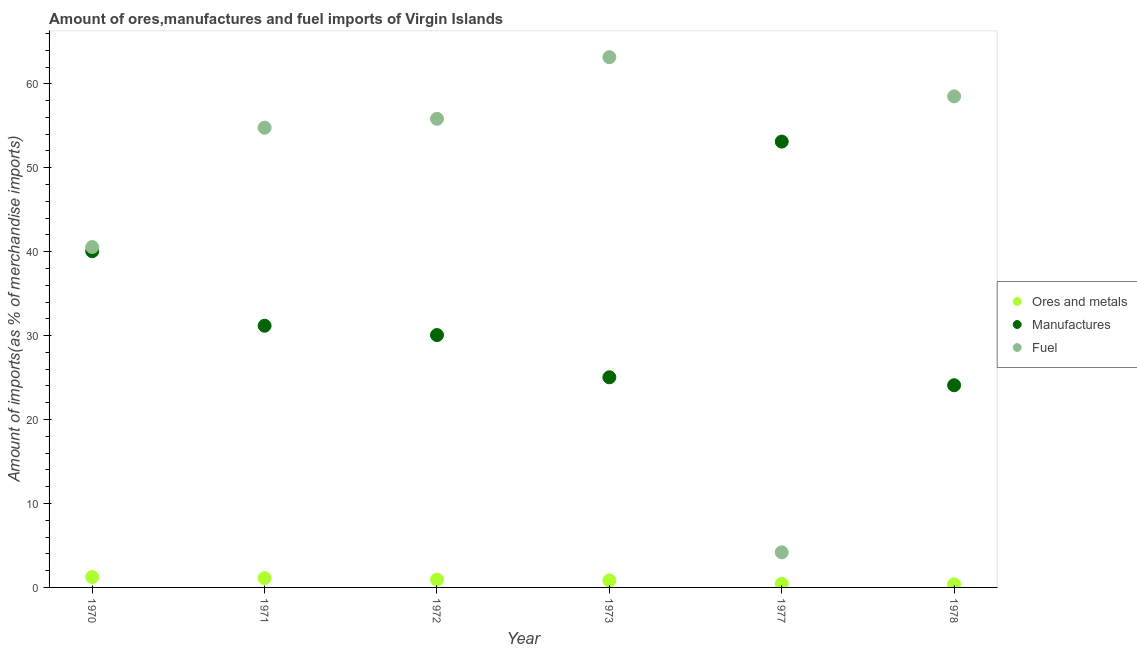How many different coloured dotlines are there?
Provide a short and direct response. 3. Is the number of dotlines equal to the number of legend labels?
Give a very brief answer. Yes. What is the percentage of ores and metals imports in 1970?
Give a very brief answer. 1.24. Across all years, what is the maximum percentage of fuel imports?
Provide a short and direct response. 63.18. Across all years, what is the minimum percentage of manufactures imports?
Ensure brevity in your answer.  24.09. In which year was the percentage of ores and metals imports minimum?
Your response must be concise. 1978. What is the total percentage of manufactures imports in the graph?
Keep it short and to the point. 203.55. What is the difference between the percentage of fuel imports in 1971 and that in 1973?
Keep it short and to the point. -8.41. What is the difference between the percentage of manufactures imports in 1977 and the percentage of ores and metals imports in 1973?
Make the answer very short. 52.28. What is the average percentage of fuel imports per year?
Keep it short and to the point. 46.17. In the year 1978, what is the difference between the percentage of manufactures imports and percentage of ores and metals imports?
Make the answer very short. 23.72. What is the ratio of the percentage of ores and metals imports in 1970 to that in 1973?
Offer a terse response. 1.48. Is the percentage of manufactures imports in 1971 less than that in 1977?
Your answer should be very brief. Yes. What is the difference between the highest and the second highest percentage of ores and metals imports?
Your answer should be very brief. 0.13. What is the difference between the highest and the lowest percentage of ores and metals imports?
Your answer should be very brief. 0.87. In how many years, is the percentage of ores and metals imports greater than the average percentage of ores and metals imports taken over all years?
Ensure brevity in your answer.  4. Is the sum of the percentage of manufactures imports in 1970 and 1973 greater than the maximum percentage of ores and metals imports across all years?
Your response must be concise. Yes. Is the percentage of manufactures imports strictly less than the percentage of ores and metals imports over the years?
Ensure brevity in your answer.  No. How many dotlines are there?
Your response must be concise. 3. Does the graph contain grids?
Give a very brief answer. No. Where does the legend appear in the graph?
Offer a terse response. Center right. What is the title of the graph?
Give a very brief answer. Amount of ores,manufactures and fuel imports of Virgin Islands. What is the label or title of the X-axis?
Make the answer very short. Year. What is the label or title of the Y-axis?
Offer a very short reply. Amount of imports(as % of merchandise imports). What is the Amount of imports(as % of merchandise imports) of Ores and metals in 1970?
Keep it short and to the point. 1.24. What is the Amount of imports(as % of merchandise imports) of Manufactures in 1970?
Make the answer very short. 40.06. What is the Amount of imports(as % of merchandise imports) in Fuel in 1970?
Ensure brevity in your answer.  40.55. What is the Amount of imports(as % of merchandise imports) in Ores and metals in 1971?
Your answer should be very brief. 1.11. What is the Amount of imports(as % of merchandise imports) in Manufactures in 1971?
Your answer should be compact. 31.18. What is the Amount of imports(as % of merchandise imports) of Fuel in 1971?
Your answer should be compact. 54.77. What is the Amount of imports(as % of merchandise imports) of Ores and metals in 1972?
Your answer should be compact. 0.93. What is the Amount of imports(as % of merchandise imports) of Manufactures in 1972?
Provide a succinct answer. 30.07. What is the Amount of imports(as % of merchandise imports) in Fuel in 1972?
Give a very brief answer. 55.83. What is the Amount of imports(as % of merchandise imports) of Ores and metals in 1973?
Give a very brief answer. 0.83. What is the Amount of imports(as % of merchandise imports) in Manufactures in 1973?
Offer a very short reply. 25.04. What is the Amount of imports(as % of merchandise imports) of Fuel in 1973?
Your answer should be compact. 63.18. What is the Amount of imports(as % of merchandise imports) of Ores and metals in 1977?
Your answer should be very brief. 0.43. What is the Amount of imports(as % of merchandise imports) in Manufactures in 1977?
Your answer should be very brief. 53.12. What is the Amount of imports(as % of merchandise imports) of Fuel in 1977?
Your response must be concise. 4.18. What is the Amount of imports(as % of merchandise imports) in Ores and metals in 1978?
Provide a succinct answer. 0.37. What is the Amount of imports(as % of merchandise imports) in Manufactures in 1978?
Offer a very short reply. 24.09. What is the Amount of imports(as % of merchandise imports) in Fuel in 1978?
Offer a very short reply. 58.5. Across all years, what is the maximum Amount of imports(as % of merchandise imports) of Ores and metals?
Make the answer very short. 1.24. Across all years, what is the maximum Amount of imports(as % of merchandise imports) in Manufactures?
Keep it short and to the point. 53.12. Across all years, what is the maximum Amount of imports(as % of merchandise imports) of Fuel?
Your answer should be very brief. 63.18. Across all years, what is the minimum Amount of imports(as % of merchandise imports) of Ores and metals?
Provide a succinct answer. 0.37. Across all years, what is the minimum Amount of imports(as % of merchandise imports) of Manufactures?
Your response must be concise. 24.09. Across all years, what is the minimum Amount of imports(as % of merchandise imports) in Fuel?
Provide a succinct answer. 4.18. What is the total Amount of imports(as % of merchandise imports) of Ores and metals in the graph?
Make the answer very short. 4.92. What is the total Amount of imports(as % of merchandise imports) of Manufactures in the graph?
Offer a very short reply. 203.55. What is the total Amount of imports(as % of merchandise imports) in Fuel in the graph?
Keep it short and to the point. 277.02. What is the difference between the Amount of imports(as % of merchandise imports) of Ores and metals in 1970 and that in 1971?
Ensure brevity in your answer.  0.13. What is the difference between the Amount of imports(as % of merchandise imports) of Manufactures in 1970 and that in 1971?
Offer a very short reply. 8.88. What is the difference between the Amount of imports(as % of merchandise imports) in Fuel in 1970 and that in 1971?
Provide a short and direct response. -14.22. What is the difference between the Amount of imports(as % of merchandise imports) of Ores and metals in 1970 and that in 1972?
Offer a very short reply. 0.31. What is the difference between the Amount of imports(as % of merchandise imports) in Manufactures in 1970 and that in 1972?
Offer a terse response. 9.99. What is the difference between the Amount of imports(as % of merchandise imports) in Fuel in 1970 and that in 1972?
Provide a succinct answer. -15.28. What is the difference between the Amount of imports(as % of merchandise imports) of Ores and metals in 1970 and that in 1973?
Keep it short and to the point. 0.4. What is the difference between the Amount of imports(as % of merchandise imports) in Manufactures in 1970 and that in 1973?
Your answer should be compact. 15.02. What is the difference between the Amount of imports(as % of merchandise imports) in Fuel in 1970 and that in 1973?
Your response must be concise. -22.62. What is the difference between the Amount of imports(as % of merchandise imports) of Ores and metals in 1970 and that in 1977?
Make the answer very short. 0.8. What is the difference between the Amount of imports(as % of merchandise imports) of Manufactures in 1970 and that in 1977?
Ensure brevity in your answer.  -13.06. What is the difference between the Amount of imports(as % of merchandise imports) in Fuel in 1970 and that in 1977?
Ensure brevity in your answer.  36.37. What is the difference between the Amount of imports(as % of merchandise imports) of Ores and metals in 1970 and that in 1978?
Your answer should be compact. 0.87. What is the difference between the Amount of imports(as % of merchandise imports) of Manufactures in 1970 and that in 1978?
Provide a succinct answer. 15.97. What is the difference between the Amount of imports(as % of merchandise imports) in Fuel in 1970 and that in 1978?
Your answer should be very brief. -17.95. What is the difference between the Amount of imports(as % of merchandise imports) of Ores and metals in 1971 and that in 1972?
Give a very brief answer. 0.18. What is the difference between the Amount of imports(as % of merchandise imports) of Manufactures in 1971 and that in 1972?
Provide a short and direct response. 1.11. What is the difference between the Amount of imports(as % of merchandise imports) in Fuel in 1971 and that in 1972?
Keep it short and to the point. -1.06. What is the difference between the Amount of imports(as % of merchandise imports) of Ores and metals in 1971 and that in 1973?
Provide a succinct answer. 0.27. What is the difference between the Amount of imports(as % of merchandise imports) in Manufactures in 1971 and that in 1973?
Your answer should be very brief. 6.14. What is the difference between the Amount of imports(as % of merchandise imports) of Fuel in 1971 and that in 1973?
Give a very brief answer. -8.41. What is the difference between the Amount of imports(as % of merchandise imports) in Ores and metals in 1971 and that in 1977?
Provide a succinct answer. 0.67. What is the difference between the Amount of imports(as % of merchandise imports) in Manufactures in 1971 and that in 1977?
Offer a very short reply. -21.94. What is the difference between the Amount of imports(as % of merchandise imports) in Fuel in 1971 and that in 1977?
Make the answer very short. 50.59. What is the difference between the Amount of imports(as % of merchandise imports) of Ores and metals in 1971 and that in 1978?
Offer a terse response. 0.74. What is the difference between the Amount of imports(as % of merchandise imports) in Manufactures in 1971 and that in 1978?
Your answer should be compact. 7.09. What is the difference between the Amount of imports(as % of merchandise imports) in Fuel in 1971 and that in 1978?
Your answer should be compact. -3.74. What is the difference between the Amount of imports(as % of merchandise imports) of Ores and metals in 1972 and that in 1973?
Make the answer very short. 0.09. What is the difference between the Amount of imports(as % of merchandise imports) of Manufactures in 1972 and that in 1973?
Provide a short and direct response. 5.03. What is the difference between the Amount of imports(as % of merchandise imports) of Fuel in 1972 and that in 1973?
Make the answer very short. -7.34. What is the difference between the Amount of imports(as % of merchandise imports) of Ores and metals in 1972 and that in 1977?
Give a very brief answer. 0.49. What is the difference between the Amount of imports(as % of merchandise imports) in Manufactures in 1972 and that in 1977?
Offer a terse response. -23.05. What is the difference between the Amount of imports(as % of merchandise imports) of Fuel in 1972 and that in 1977?
Provide a succinct answer. 51.65. What is the difference between the Amount of imports(as % of merchandise imports) in Ores and metals in 1972 and that in 1978?
Provide a succinct answer. 0.56. What is the difference between the Amount of imports(as % of merchandise imports) in Manufactures in 1972 and that in 1978?
Your answer should be compact. 5.98. What is the difference between the Amount of imports(as % of merchandise imports) of Fuel in 1972 and that in 1978?
Provide a succinct answer. -2.67. What is the difference between the Amount of imports(as % of merchandise imports) of Ores and metals in 1973 and that in 1977?
Give a very brief answer. 0.4. What is the difference between the Amount of imports(as % of merchandise imports) of Manufactures in 1973 and that in 1977?
Keep it short and to the point. -28.08. What is the difference between the Amount of imports(as % of merchandise imports) in Fuel in 1973 and that in 1977?
Your answer should be very brief. 59. What is the difference between the Amount of imports(as % of merchandise imports) of Ores and metals in 1973 and that in 1978?
Your answer should be compact. 0.46. What is the difference between the Amount of imports(as % of merchandise imports) in Manufactures in 1973 and that in 1978?
Your answer should be compact. 0.95. What is the difference between the Amount of imports(as % of merchandise imports) in Fuel in 1973 and that in 1978?
Your answer should be compact. 4.67. What is the difference between the Amount of imports(as % of merchandise imports) in Ores and metals in 1977 and that in 1978?
Provide a short and direct response. 0.06. What is the difference between the Amount of imports(as % of merchandise imports) of Manufactures in 1977 and that in 1978?
Offer a terse response. 29.03. What is the difference between the Amount of imports(as % of merchandise imports) of Fuel in 1977 and that in 1978?
Provide a succinct answer. -54.32. What is the difference between the Amount of imports(as % of merchandise imports) of Ores and metals in 1970 and the Amount of imports(as % of merchandise imports) of Manufactures in 1971?
Make the answer very short. -29.94. What is the difference between the Amount of imports(as % of merchandise imports) of Ores and metals in 1970 and the Amount of imports(as % of merchandise imports) of Fuel in 1971?
Your answer should be very brief. -53.53. What is the difference between the Amount of imports(as % of merchandise imports) of Manufactures in 1970 and the Amount of imports(as % of merchandise imports) of Fuel in 1971?
Ensure brevity in your answer.  -14.71. What is the difference between the Amount of imports(as % of merchandise imports) in Ores and metals in 1970 and the Amount of imports(as % of merchandise imports) in Manufactures in 1972?
Ensure brevity in your answer.  -28.83. What is the difference between the Amount of imports(as % of merchandise imports) of Ores and metals in 1970 and the Amount of imports(as % of merchandise imports) of Fuel in 1972?
Offer a terse response. -54.59. What is the difference between the Amount of imports(as % of merchandise imports) in Manufactures in 1970 and the Amount of imports(as % of merchandise imports) in Fuel in 1972?
Ensure brevity in your answer.  -15.77. What is the difference between the Amount of imports(as % of merchandise imports) of Ores and metals in 1970 and the Amount of imports(as % of merchandise imports) of Manufactures in 1973?
Offer a terse response. -23.8. What is the difference between the Amount of imports(as % of merchandise imports) in Ores and metals in 1970 and the Amount of imports(as % of merchandise imports) in Fuel in 1973?
Your answer should be compact. -61.94. What is the difference between the Amount of imports(as % of merchandise imports) in Manufactures in 1970 and the Amount of imports(as % of merchandise imports) in Fuel in 1973?
Provide a succinct answer. -23.12. What is the difference between the Amount of imports(as % of merchandise imports) in Ores and metals in 1970 and the Amount of imports(as % of merchandise imports) in Manufactures in 1977?
Keep it short and to the point. -51.88. What is the difference between the Amount of imports(as % of merchandise imports) of Ores and metals in 1970 and the Amount of imports(as % of merchandise imports) of Fuel in 1977?
Provide a succinct answer. -2.94. What is the difference between the Amount of imports(as % of merchandise imports) of Manufactures in 1970 and the Amount of imports(as % of merchandise imports) of Fuel in 1977?
Your answer should be very brief. 35.88. What is the difference between the Amount of imports(as % of merchandise imports) of Ores and metals in 1970 and the Amount of imports(as % of merchandise imports) of Manufactures in 1978?
Ensure brevity in your answer.  -22.85. What is the difference between the Amount of imports(as % of merchandise imports) of Ores and metals in 1970 and the Amount of imports(as % of merchandise imports) of Fuel in 1978?
Provide a succinct answer. -57.27. What is the difference between the Amount of imports(as % of merchandise imports) of Manufactures in 1970 and the Amount of imports(as % of merchandise imports) of Fuel in 1978?
Ensure brevity in your answer.  -18.44. What is the difference between the Amount of imports(as % of merchandise imports) in Ores and metals in 1971 and the Amount of imports(as % of merchandise imports) in Manufactures in 1972?
Make the answer very short. -28.96. What is the difference between the Amount of imports(as % of merchandise imports) of Ores and metals in 1971 and the Amount of imports(as % of merchandise imports) of Fuel in 1972?
Offer a very short reply. -54.72. What is the difference between the Amount of imports(as % of merchandise imports) of Manufactures in 1971 and the Amount of imports(as % of merchandise imports) of Fuel in 1972?
Offer a very short reply. -24.66. What is the difference between the Amount of imports(as % of merchandise imports) of Ores and metals in 1971 and the Amount of imports(as % of merchandise imports) of Manufactures in 1973?
Offer a terse response. -23.93. What is the difference between the Amount of imports(as % of merchandise imports) in Ores and metals in 1971 and the Amount of imports(as % of merchandise imports) in Fuel in 1973?
Offer a terse response. -62.07. What is the difference between the Amount of imports(as % of merchandise imports) of Manufactures in 1971 and the Amount of imports(as % of merchandise imports) of Fuel in 1973?
Your response must be concise. -32. What is the difference between the Amount of imports(as % of merchandise imports) of Ores and metals in 1971 and the Amount of imports(as % of merchandise imports) of Manufactures in 1977?
Make the answer very short. -52.01. What is the difference between the Amount of imports(as % of merchandise imports) of Ores and metals in 1971 and the Amount of imports(as % of merchandise imports) of Fuel in 1977?
Give a very brief answer. -3.07. What is the difference between the Amount of imports(as % of merchandise imports) of Manufactures in 1971 and the Amount of imports(as % of merchandise imports) of Fuel in 1977?
Your response must be concise. 27. What is the difference between the Amount of imports(as % of merchandise imports) in Ores and metals in 1971 and the Amount of imports(as % of merchandise imports) in Manufactures in 1978?
Make the answer very short. -22.98. What is the difference between the Amount of imports(as % of merchandise imports) of Ores and metals in 1971 and the Amount of imports(as % of merchandise imports) of Fuel in 1978?
Offer a very short reply. -57.4. What is the difference between the Amount of imports(as % of merchandise imports) in Manufactures in 1971 and the Amount of imports(as % of merchandise imports) in Fuel in 1978?
Offer a terse response. -27.33. What is the difference between the Amount of imports(as % of merchandise imports) of Ores and metals in 1972 and the Amount of imports(as % of merchandise imports) of Manufactures in 1973?
Your response must be concise. -24.11. What is the difference between the Amount of imports(as % of merchandise imports) of Ores and metals in 1972 and the Amount of imports(as % of merchandise imports) of Fuel in 1973?
Offer a very short reply. -62.25. What is the difference between the Amount of imports(as % of merchandise imports) in Manufactures in 1972 and the Amount of imports(as % of merchandise imports) in Fuel in 1973?
Keep it short and to the point. -33.11. What is the difference between the Amount of imports(as % of merchandise imports) of Ores and metals in 1972 and the Amount of imports(as % of merchandise imports) of Manufactures in 1977?
Offer a terse response. -52.19. What is the difference between the Amount of imports(as % of merchandise imports) in Ores and metals in 1972 and the Amount of imports(as % of merchandise imports) in Fuel in 1977?
Your response must be concise. -3.25. What is the difference between the Amount of imports(as % of merchandise imports) in Manufactures in 1972 and the Amount of imports(as % of merchandise imports) in Fuel in 1977?
Offer a very short reply. 25.89. What is the difference between the Amount of imports(as % of merchandise imports) of Ores and metals in 1972 and the Amount of imports(as % of merchandise imports) of Manufactures in 1978?
Offer a very short reply. -23.16. What is the difference between the Amount of imports(as % of merchandise imports) in Ores and metals in 1972 and the Amount of imports(as % of merchandise imports) in Fuel in 1978?
Provide a short and direct response. -57.58. What is the difference between the Amount of imports(as % of merchandise imports) in Manufactures in 1972 and the Amount of imports(as % of merchandise imports) in Fuel in 1978?
Your answer should be very brief. -28.44. What is the difference between the Amount of imports(as % of merchandise imports) of Ores and metals in 1973 and the Amount of imports(as % of merchandise imports) of Manufactures in 1977?
Provide a succinct answer. -52.28. What is the difference between the Amount of imports(as % of merchandise imports) of Ores and metals in 1973 and the Amount of imports(as % of merchandise imports) of Fuel in 1977?
Keep it short and to the point. -3.35. What is the difference between the Amount of imports(as % of merchandise imports) of Manufactures in 1973 and the Amount of imports(as % of merchandise imports) of Fuel in 1977?
Provide a short and direct response. 20.86. What is the difference between the Amount of imports(as % of merchandise imports) of Ores and metals in 1973 and the Amount of imports(as % of merchandise imports) of Manufactures in 1978?
Keep it short and to the point. -23.26. What is the difference between the Amount of imports(as % of merchandise imports) in Ores and metals in 1973 and the Amount of imports(as % of merchandise imports) in Fuel in 1978?
Your response must be concise. -57.67. What is the difference between the Amount of imports(as % of merchandise imports) in Manufactures in 1973 and the Amount of imports(as % of merchandise imports) in Fuel in 1978?
Ensure brevity in your answer.  -33.47. What is the difference between the Amount of imports(as % of merchandise imports) in Ores and metals in 1977 and the Amount of imports(as % of merchandise imports) in Manufactures in 1978?
Offer a terse response. -23.66. What is the difference between the Amount of imports(as % of merchandise imports) in Ores and metals in 1977 and the Amount of imports(as % of merchandise imports) in Fuel in 1978?
Offer a terse response. -58.07. What is the difference between the Amount of imports(as % of merchandise imports) of Manufactures in 1977 and the Amount of imports(as % of merchandise imports) of Fuel in 1978?
Provide a succinct answer. -5.39. What is the average Amount of imports(as % of merchandise imports) in Ores and metals per year?
Your answer should be compact. 0.82. What is the average Amount of imports(as % of merchandise imports) of Manufactures per year?
Offer a terse response. 33.92. What is the average Amount of imports(as % of merchandise imports) in Fuel per year?
Your answer should be compact. 46.17. In the year 1970, what is the difference between the Amount of imports(as % of merchandise imports) in Ores and metals and Amount of imports(as % of merchandise imports) in Manufactures?
Make the answer very short. -38.82. In the year 1970, what is the difference between the Amount of imports(as % of merchandise imports) in Ores and metals and Amount of imports(as % of merchandise imports) in Fuel?
Offer a terse response. -39.31. In the year 1970, what is the difference between the Amount of imports(as % of merchandise imports) in Manufactures and Amount of imports(as % of merchandise imports) in Fuel?
Make the answer very short. -0.49. In the year 1971, what is the difference between the Amount of imports(as % of merchandise imports) in Ores and metals and Amount of imports(as % of merchandise imports) in Manufactures?
Provide a succinct answer. -30.07. In the year 1971, what is the difference between the Amount of imports(as % of merchandise imports) in Ores and metals and Amount of imports(as % of merchandise imports) in Fuel?
Your answer should be very brief. -53.66. In the year 1971, what is the difference between the Amount of imports(as % of merchandise imports) in Manufactures and Amount of imports(as % of merchandise imports) in Fuel?
Provide a short and direct response. -23.59. In the year 1972, what is the difference between the Amount of imports(as % of merchandise imports) of Ores and metals and Amount of imports(as % of merchandise imports) of Manufactures?
Your answer should be compact. -29.14. In the year 1972, what is the difference between the Amount of imports(as % of merchandise imports) in Ores and metals and Amount of imports(as % of merchandise imports) in Fuel?
Keep it short and to the point. -54.9. In the year 1972, what is the difference between the Amount of imports(as % of merchandise imports) in Manufactures and Amount of imports(as % of merchandise imports) in Fuel?
Give a very brief answer. -25.77. In the year 1973, what is the difference between the Amount of imports(as % of merchandise imports) of Ores and metals and Amount of imports(as % of merchandise imports) of Manufactures?
Provide a short and direct response. -24.2. In the year 1973, what is the difference between the Amount of imports(as % of merchandise imports) in Ores and metals and Amount of imports(as % of merchandise imports) in Fuel?
Give a very brief answer. -62.34. In the year 1973, what is the difference between the Amount of imports(as % of merchandise imports) of Manufactures and Amount of imports(as % of merchandise imports) of Fuel?
Make the answer very short. -38.14. In the year 1977, what is the difference between the Amount of imports(as % of merchandise imports) in Ores and metals and Amount of imports(as % of merchandise imports) in Manufactures?
Offer a terse response. -52.68. In the year 1977, what is the difference between the Amount of imports(as % of merchandise imports) in Ores and metals and Amount of imports(as % of merchandise imports) in Fuel?
Ensure brevity in your answer.  -3.75. In the year 1977, what is the difference between the Amount of imports(as % of merchandise imports) of Manufactures and Amount of imports(as % of merchandise imports) of Fuel?
Your answer should be compact. 48.94. In the year 1978, what is the difference between the Amount of imports(as % of merchandise imports) in Ores and metals and Amount of imports(as % of merchandise imports) in Manufactures?
Your answer should be compact. -23.72. In the year 1978, what is the difference between the Amount of imports(as % of merchandise imports) of Ores and metals and Amount of imports(as % of merchandise imports) of Fuel?
Offer a very short reply. -58.13. In the year 1978, what is the difference between the Amount of imports(as % of merchandise imports) of Manufactures and Amount of imports(as % of merchandise imports) of Fuel?
Offer a terse response. -34.41. What is the ratio of the Amount of imports(as % of merchandise imports) of Ores and metals in 1970 to that in 1971?
Your answer should be very brief. 1.12. What is the ratio of the Amount of imports(as % of merchandise imports) of Manufactures in 1970 to that in 1971?
Give a very brief answer. 1.28. What is the ratio of the Amount of imports(as % of merchandise imports) in Fuel in 1970 to that in 1971?
Give a very brief answer. 0.74. What is the ratio of the Amount of imports(as % of merchandise imports) of Ores and metals in 1970 to that in 1972?
Ensure brevity in your answer.  1.33. What is the ratio of the Amount of imports(as % of merchandise imports) in Manufactures in 1970 to that in 1972?
Ensure brevity in your answer.  1.33. What is the ratio of the Amount of imports(as % of merchandise imports) in Fuel in 1970 to that in 1972?
Keep it short and to the point. 0.73. What is the ratio of the Amount of imports(as % of merchandise imports) in Ores and metals in 1970 to that in 1973?
Provide a succinct answer. 1.48. What is the ratio of the Amount of imports(as % of merchandise imports) in Manufactures in 1970 to that in 1973?
Offer a very short reply. 1.6. What is the ratio of the Amount of imports(as % of merchandise imports) in Fuel in 1970 to that in 1973?
Make the answer very short. 0.64. What is the ratio of the Amount of imports(as % of merchandise imports) in Ores and metals in 1970 to that in 1977?
Offer a very short reply. 2.85. What is the ratio of the Amount of imports(as % of merchandise imports) in Manufactures in 1970 to that in 1977?
Keep it short and to the point. 0.75. What is the ratio of the Amount of imports(as % of merchandise imports) in Fuel in 1970 to that in 1977?
Your answer should be very brief. 9.7. What is the ratio of the Amount of imports(as % of merchandise imports) in Ores and metals in 1970 to that in 1978?
Keep it short and to the point. 3.33. What is the ratio of the Amount of imports(as % of merchandise imports) of Manufactures in 1970 to that in 1978?
Your answer should be very brief. 1.66. What is the ratio of the Amount of imports(as % of merchandise imports) in Fuel in 1970 to that in 1978?
Give a very brief answer. 0.69. What is the ratio of the Amount of imports(as % of merchandise imports) of Ores and metals in 1971 to that in 1972?
Ensure brevity in your answer.  1.19. What is the ratio of the Amount of imports(as % of merchandise imports) in Manufactures in 1971 to that in 1972?
Keep it short and to the point. 1.04. What is the ratio of the Amount of imports(as % of merchandise imports) in Fuel in 1971 to that in 1972?
Provide a succinct answer. 0.98. What is the ratio of the Amount of imports(as % of merchandise imports) in Ores and metals in 1971 to that in 1973?
Make the answer very short. 1.33. What is the ratio of the Amount of imports(as % of merchandise imports) in Manufactures in 1971 to that in 1973?
Provide a succinct answer. 1.25. What is the ratio of the Amount of imports(as % of merchandise imports) in Fuel in 1971 to that in 1973?
Offer a very short reply. 0.87. What is the ratio of the Amount of imports(as % of merchandise imports) of Ores and metals in 1971 to that in 1977?
Provide a succinct answer. 2.55. What is the ratio of the Amount of imports(as % of merchandise imports) of Manufactures in 1971 to that in 1977?
Give a very brief answer. 0.59. What is the ratio of the Amount of imports(as % of merchandise imports) in Fuel in 1971 to that in 1977?
Provide a short and direct response. 13.1. What is the ratio of the Amount of imports(as % of merchandise imports) in Ores and metals in 1971 to that in 1978?
Your response must be concise. 2.98. What is the ratio of the Amount of imports(as % of merchandise imports) of Manufactures in 1971 to that in 1978?
Your response must be concise. 1.29. What is the ratio of the Amount of imports(as % of merchandise imports) of Fuel in 1971 to that in 1978?
Your response must be concise. 0.94. What is the ratio of the Amount of imports(as % of merchandise imports) of Ores and metals in 1972 to that in 1973?
Your answer should be very brief. 1.11. What is the ratio of the Amount of imports(as % of merchandise imports) of Manufactures in 1972 to that in 1973?
Provide a short and direct response. 1.2. What is the ratio of the Amount of imports(as % of merchandise imports) in Fuel in 1972 to that in 1973?
Your answer should be compact. 0.88. What is the ratio of the Amount of imports(as % of merchandise imports) of Ores and metals in 1972 to that in 1977?
Offer a very short reply. 2.14. What is the ratio of the Amount of imports(as % of merchandise imports) in Manufactures in 1972 to that in 1977?
Make the answer very short. 0.57. What is the ratio of the Amount of imports(as % of merchandise imports) in Fuel in 1972 to that in 1977?
Keep it short and to the point. 13.36. What is the ratio of the Amount of imports(as % of merchandise imports) of Ores and metals in 1972 to that in 1978?
Provide a short and direct response. 2.5. What is the ratio of the Amount of imports(as % of merchandise imports) of Manufactures in 1972 to that in 1978?
Provide a succinct answer. 1.25. What is the ratio of the Amount of imports(as % of merchandise imports) of Fuel in 1972 to that in 1978?
Offer a terse response. 0.95. What is the ratio of the Amount of imports(as % of merchandise imports) in Ores and metals in 1973 to that in 1977?
Keep it short and to the point. 1.92. What is the ratio of the Amount of imports(as % of merchandise imports) of Manufactures in 1973 to that in 1977?
Offer a terse response. 0.47. What is the ratio of the Amount of imports(as % of merchandise imports) in Fuel in 1973 to that in 1977?
Your answer should be compact. 15.11. What is the ratio of the Amount of imports(as % of merchandise imports) of Ores and metals in 1973 to that in 1978?
Your answer should be compact. 2.24. What is the ratio of the Amount of imports(as % of merchandise imports) of Manufactures in 1973 to that in 1978?
Make the answer very short. 1.04. What is the ratio of the Amount of imports(as % of merchandise imports) of Fuel in 1973 to that in 1978?
Offer a very short reply. 1.08. What is the ratio of the Amount of imports(as % of merchandise imports) of Ores and metals in 1977 to that in 1978?
Provide a succinct answer. 1.17. What is the ratio of the Amount of imports(as % of merchandise imports) in Manufactures in 1977 to that in 1978?
Provide a succinct answer. 2.21. What is the ratio of the Amount of imports(as % of merchandise imports) of Fuel in 1977 to that in 1978?
Your answer should be very brief. 0.07. What is the difference between the highest and the second highest Amount of imports(as % of merchandise imports) of Ores and metals?
Keep it short and to the point. 0.13. What is the difference between the highest and the second highest Amount of imports(as % of merchandise imports) in Manufactures?
Offer a terse response. 13.06. What is the difference between the highest and the second highest Amount of imports(as % of merchandise imports) of Fuel?
Make the answer very short. 4.67. What is the difference between the highest and the lowest Amount of imports(as % of merchandise imports) of Ores and metals?
Make the answer very short. 0.87. What is the difference between the highest and the lowest Amount of imports(as % of merchandise imports) of Manufactures?
Provide a succinct answer. 29.03. What is the difference between the highest and the lowest Amount of imports(as % of merchandise imports) of Fuel?
Your answer should be compact. 59. 